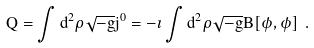Convert formula to latex. <formula><loc_0><loc_0><loc_500><loc_500>Q = \int d ^ { 2 } \rho \sqrt { - g } j ^ { 0 } = - \imath \int d ^ { 2 } \rho \sqrt { - g } B [ \phi , \dot { \phi } ] \ .</formula> 